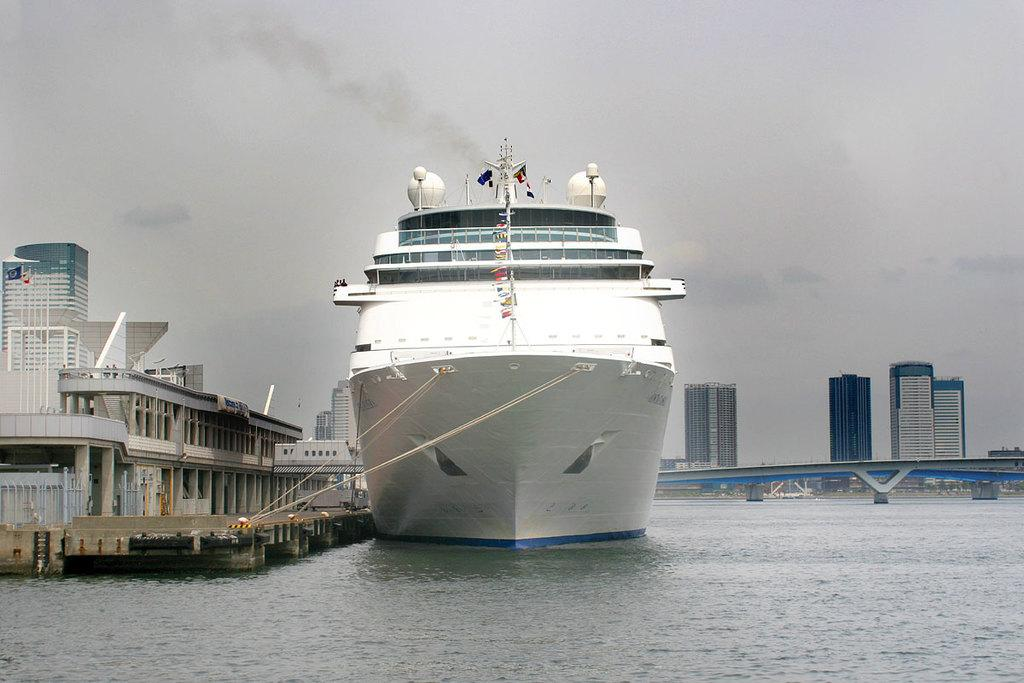What is the main subject of the image? The main subject of the image is a ship. What is the ship's current state in the image? The ship is floating on the water. What other structures can be seen in the image? There is a bridge and buildings in the image. What type of tongue can be seen in the image? There is no tongue present in the image. 